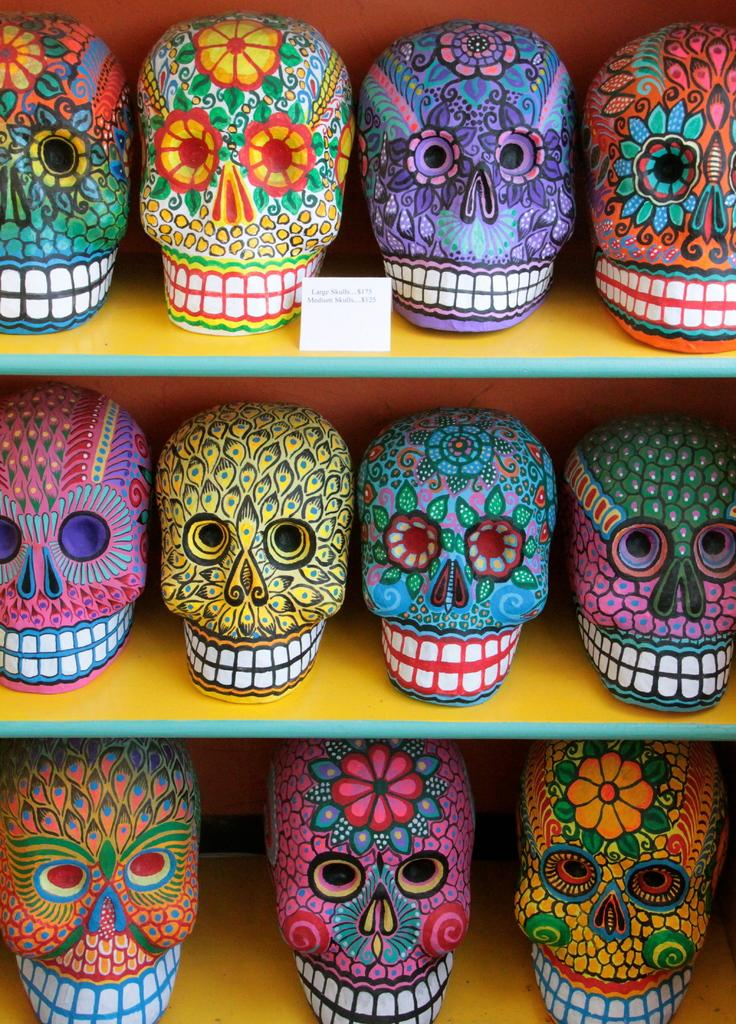What type of toys are featured in the image? There are many skull toys in the image. Where are the skull toys located in the image? The skull toys are arranged on a shelf. What type of leather is used to make the manager's chair in the image? There is no manager or chair present in the image; it only features skull toys arranged on a shelf. 